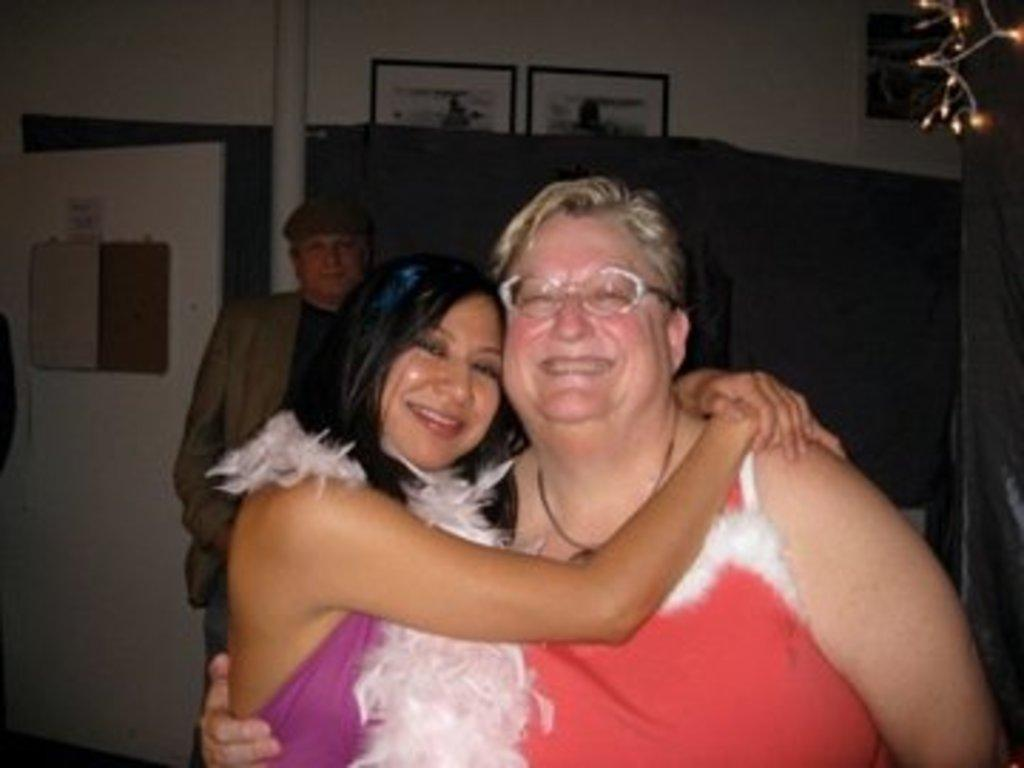Who or what is present in the image? There are people in the image. What can be seen in the background of the image? There is a wall with posters in the background of the image. What other object is visible in the image? There is a pole in the image. Where are the lights located in the image? The lights are in the top right corner of the image. What type of waste is being disposed of in the image? There is no waste present in the image. Can you identify any stars in the image? There are no stars visible in the image. 